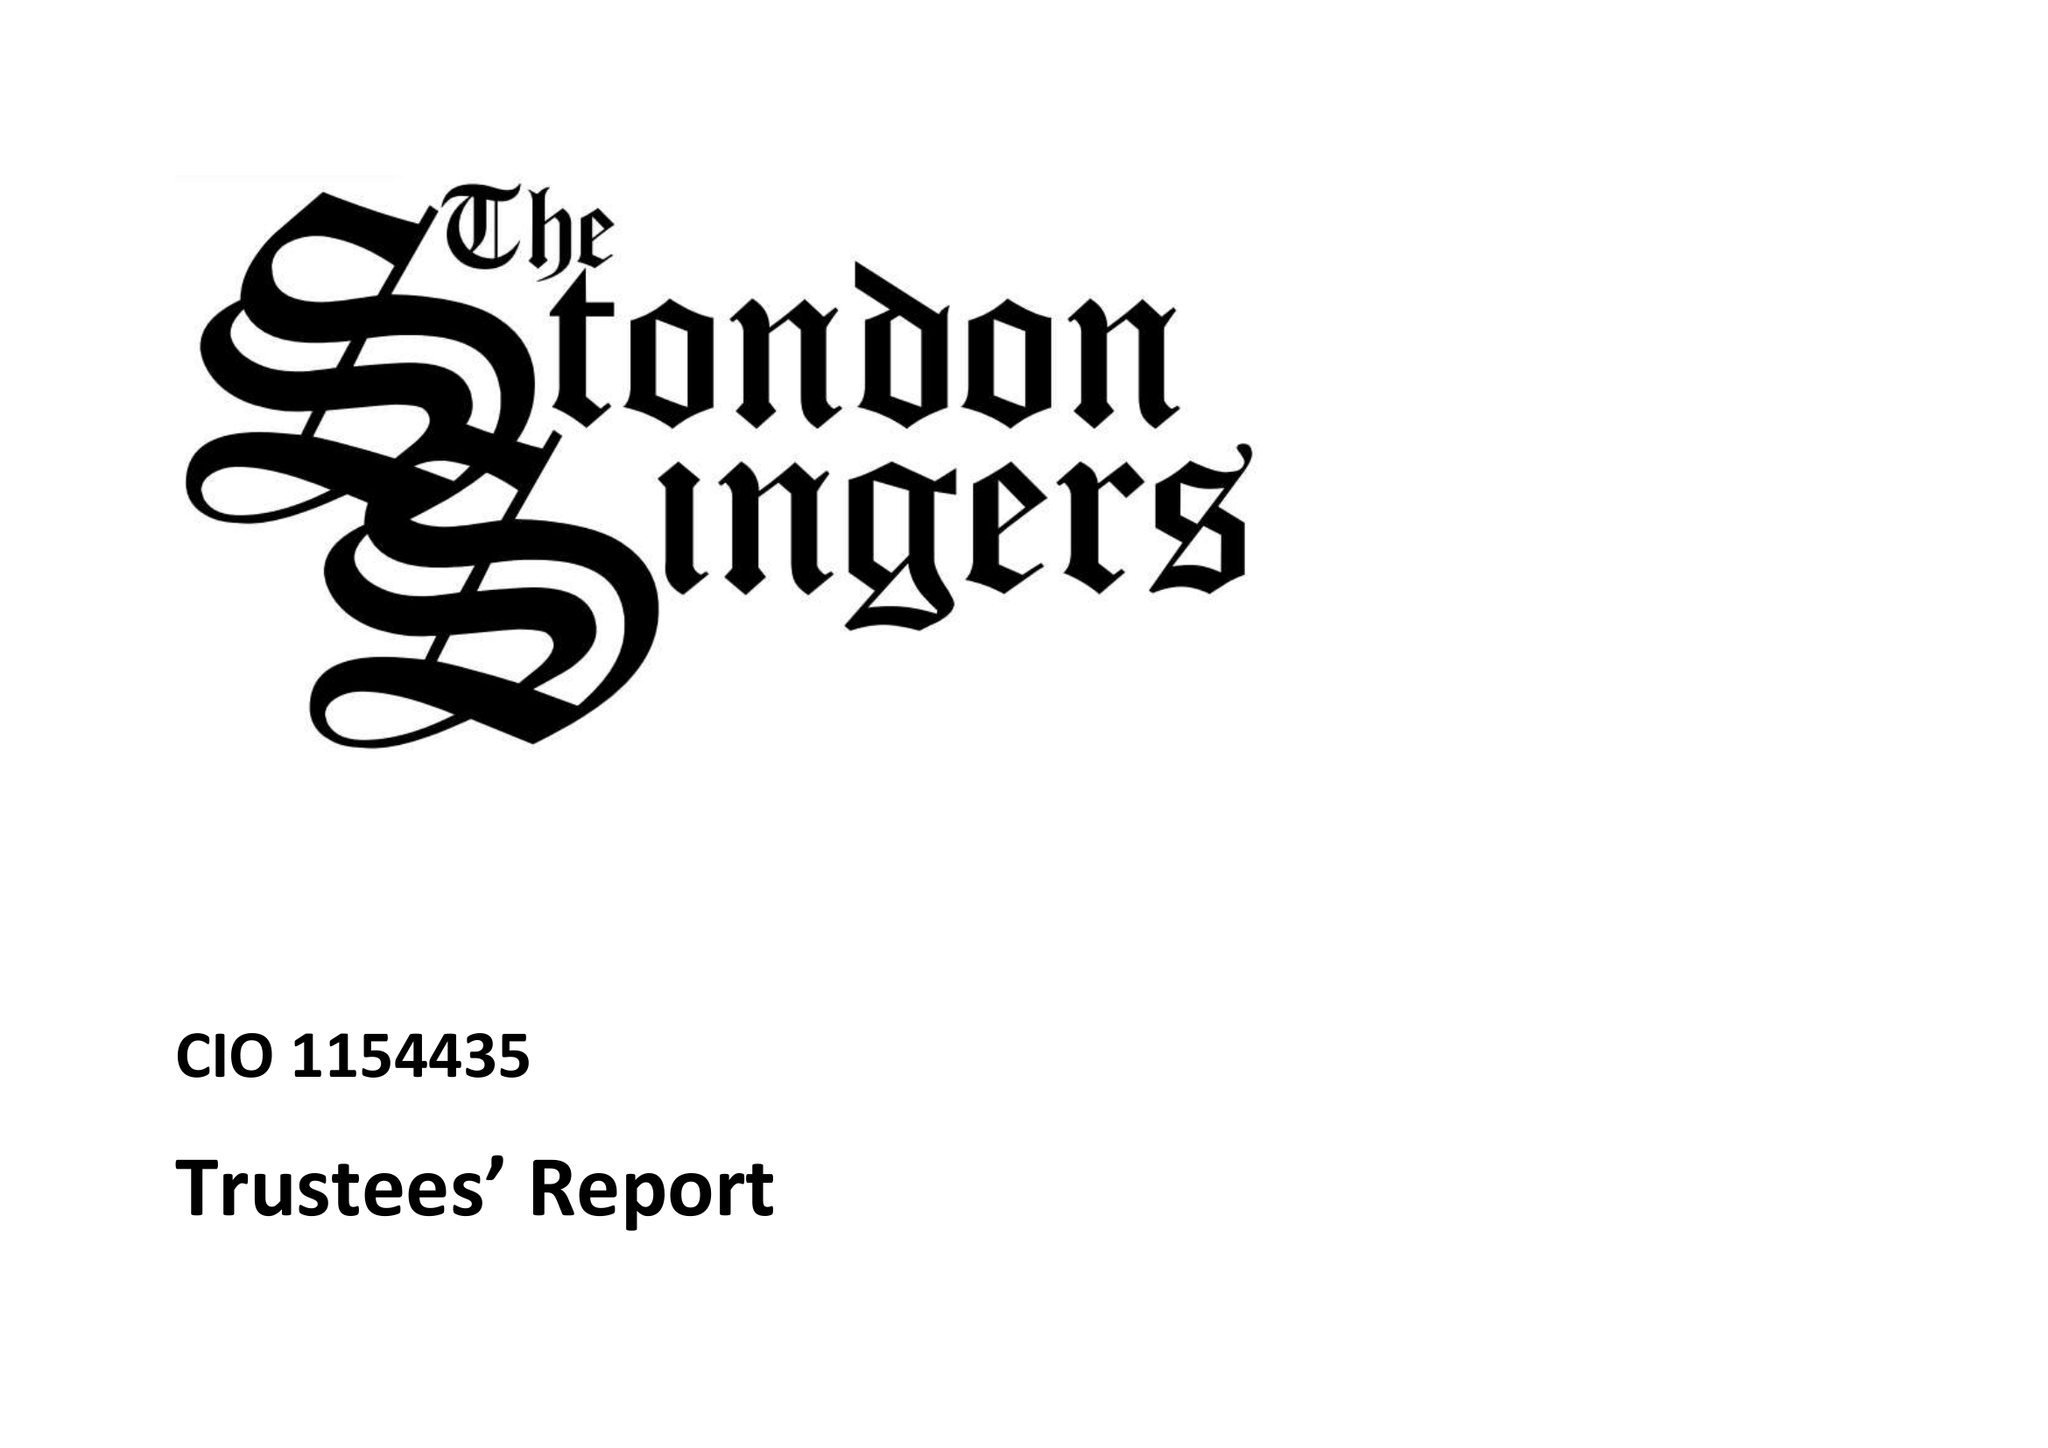What is the value for the address__street_line?
Answer the question using a single word or phrase. WIGLEY BUSH LANE 